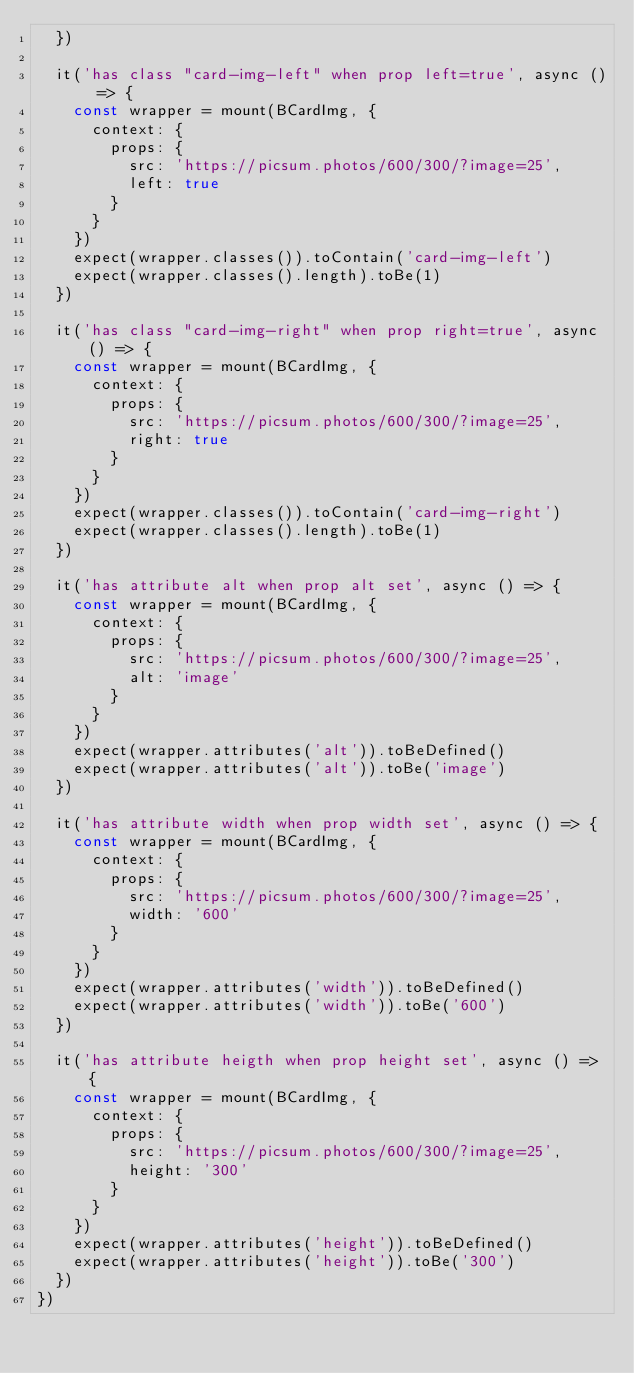<code> <loc_0><loc_0><loc_500><loc_500><_JavaScript_>  })

  it('has class "card-img-left" when prop left=true', async () => {
    const wrapper = mount(BCardImg, {
      context: {
        props: {
          src: 'https://picsum.photos/600/300/?image=25',
          left: true
        }
      }
    })
    expect(wrapper.classes()).toContain('card-img-left')
    expect(wrapper.classes().length).toBe(1)
  })

  it('has class "card-img-right" when prop right=true', async () => {
    const wrapper = mount(BCardImg, {
      context: {
        props: {
          src: 'https://picsum.photos/600/300/?image=25',
          right: true
        }
      }
    })
    expect(wrapper.classes()).toContain('card-img-right')
    expect(wrapper.classes().length).toBe(1)
  })

  it('has attribute alt when prop alt set', async () => {
    const wrapper = mount(BCardImg, {
      context: {
        props: {
          src: 'https://picsum.photos/600/300/?image=25',
          alt: 'image'
        }
      }
    })
    expect(wrapper.attributes('alt')).toBeDefined()
    expect(wrapper.attributes('alt')).toBe('image')
  })

  it('has attribute width when prop width set', async () => {
    const wrapper = mount(BCardImg, {
      context: {
        props: {
          src: 'https://picsum.photos/600/300/?image=25',
          width: '600'
        }
      }
    })
    expect(wrapper.attributes('width')).toBeDefined()
    expect(wrapper.attributes('width')).toBe('600')
  })

  it('has attribute heigth when prop height set', async () => {
    const wrapper = mount(BCardImg, {
      context: {
        props: {
          src: 'https://picsum.photos/600/300/?image=25',
          height: '300'
        }
      }
    })
    expect(wrapper.attributes('height')).toBeDefined()
    expect(wrapper.attributes('height')).toBe('300')
  })
})
</code> 